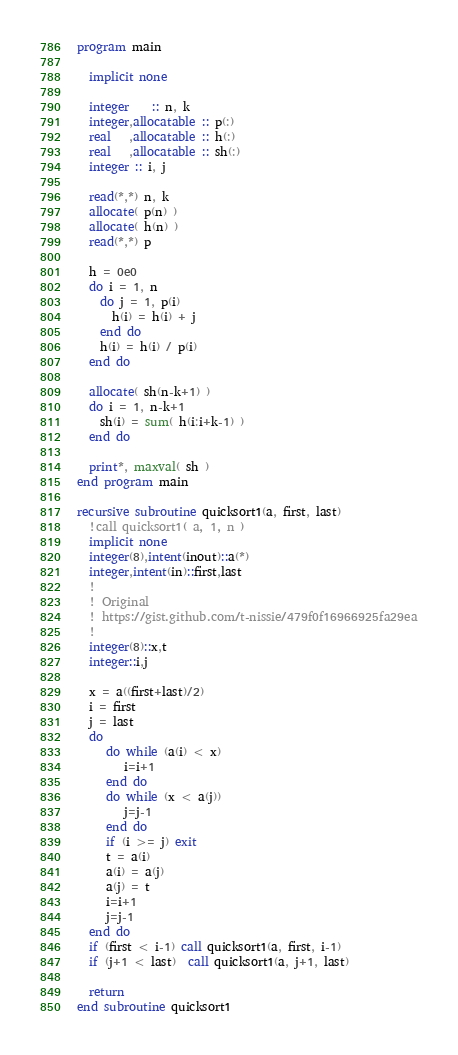Convert code to text. <code><loc_0><loc_0><loc_500><loc_500><_FORTRAN_>program main

  implicit none

  integer    :: n, k
  integer,allocatable :: p(:)
  real   ,allocatable :: h(:)
  real   ,allocatable :: sh(:)
  integer :: i, j 
  
  read(*,*) n, k
  allocate( p(n) )
  allocate( h(n) )
  read(*,*) p

  h = 0e0 
  do i = 1, n
    do j = 1, p(i)
      h(i) = h(i) + j 
    end do
    h(i) = h(i) / p(i) 
  end do

  allocate( sh(n-k+1) )
  do i = 1, n-k+1
    sh(i) = sum( h(i:i+k-1) )
  end do
  
  print*, maxval( sh )
end program main

recursive subroutine quicksort1(a, first, last)
  !call quicksort1( a, 1, n ) 
  implicit none
  integer(8),intent(inout)::a(*)
  integer,intent(in)::first,last
  !
  ! Original
  ! https://gist.github.com/t-nissie/479f0f16966925fa29ea
  !
  integer(8)::x,t
  integer::i,j

  x = a((first+last)/2)
  i = first
  j = last
  do
     do while (a(i) < x)
        i=i+1
     end do
     do while (x < a(j))
        j=j-1
     end do
     if (i >= j) exit
     t = a(i)
     a(i) = a(j)
     a(j) = t
     i=i+1
     j=j-1
  end do
  if (first < i-1) call quicksort1(a, first, i-1)
  if (j+1 < last)  call quicksort1(a, j+1, last)

  return
end subroutine quicksort1
</code> 